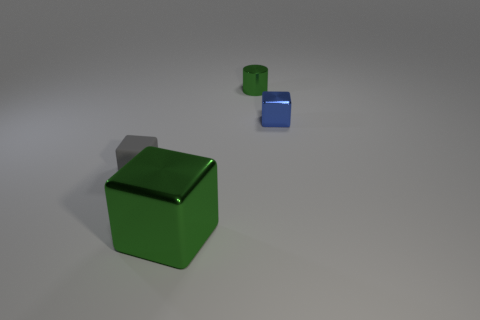Is there anything else that has the same material as the tiny green object?
Offer a terse response. Yes. How many tiny metallic things have the same color as the matte object?
Offer a terse response. 0. Are there fewer green objects that are right of the large shiny cube than metal blocks to the right of the tiny matte thing?
Your answer should be compact. Yes. There is a gray rubber thing; are there any green cylinders right of it?
Offer a terse response. Yes. There is a green metal thing that is in front of the thing that is on the right side of the green cylinder; are there any tiny gray things to the left of it?
Offer a very short reply. Yes. Do the object that is behind the blue metal block and the blue object have the same shape?
Offer a terse response. No. There is a small thing that is the same material as the small cylinder; what color is it?
Your answer should be compact. Blue. What number of other green objects are the same material as the big thing?
Give a very brief answer. 1. There is a object to the right of the green object that is behind the small block left of the big green thing; what color is it?
Make the answer very short. Blue. Does the gray rubber cube have the same size as the blue cube?
Give a very brief answer. Yes. 